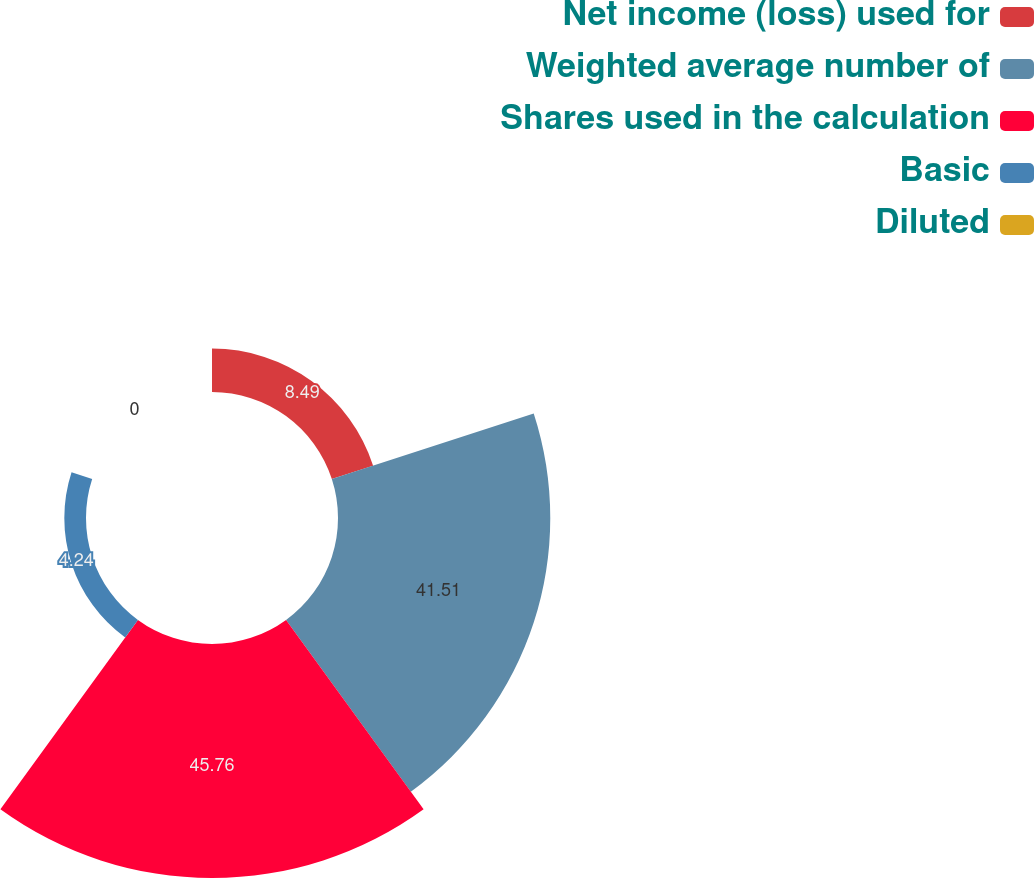Convert chart to OTSL. <chart><loc_0><loc_0><loc_500><loc_500><pie_chart><fcel>Net income (loss) used for<fcel>Weighted average number of<fcel>Shares used in the calculation<fcel>Basic<fcel>Diluted<nl><fcel>8.49%<fcel>41.51%<fcel>45.76%<fcel>4.24%<fcel>0.0%<nl></chart> 